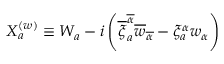Convert formula to latex. <formula><loc_0><loc_0><loc_500><loc_500>X _ { a } ^ { ( w ) } \equiv W _ { a } - i \left ( \overline { \xi } _ { a } ^ { \overline { \alpha } } \overline { w } _ { \overline { \alpha } } - \xi _ { a } ^ { \alpha } w _ { \alpha } \right )</formula> 